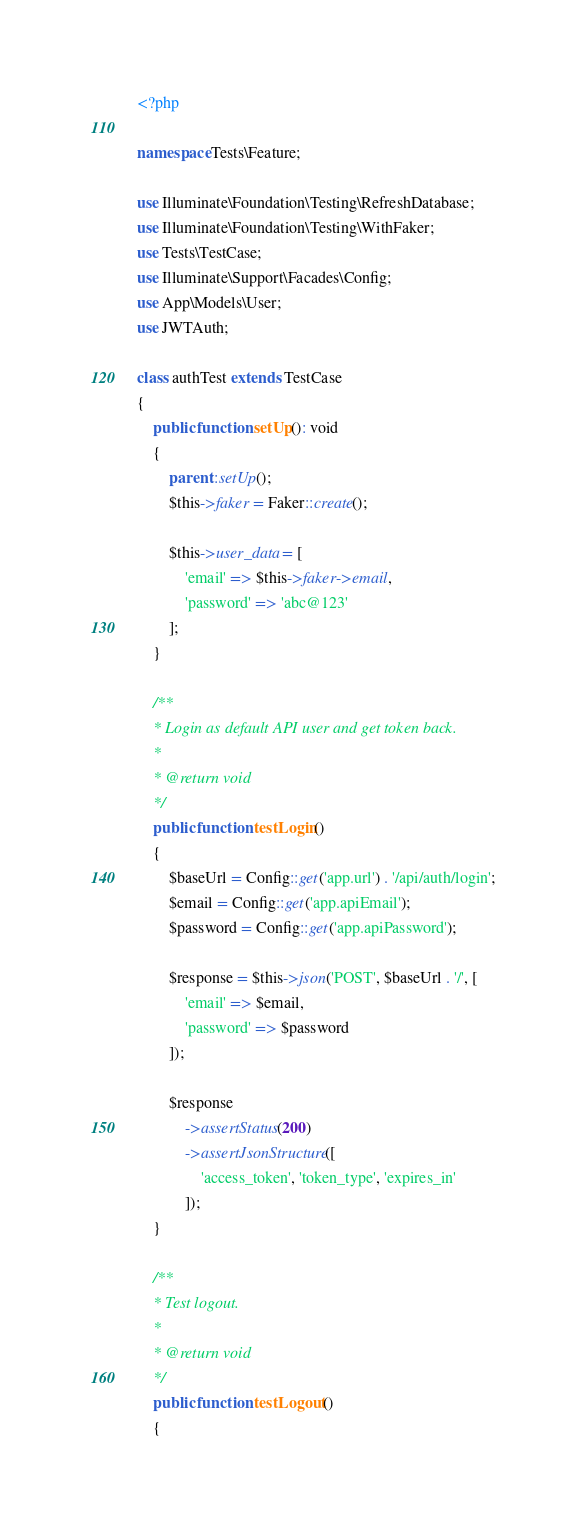<code> <loc_0><loc_0><loc_500><loc_500><_PHP_><?php

namespace Tests\Feature;

use Illuminate\Foundation\Testing\RefreshDatabase;
use Illuminate\Foundation\Testing\WithFaker;
use Tests\TestCase;
use Illuminate\Support\Facades\Config;
use App\Models\User;
use JWTAuth;

class authTest extends TestCase
{
    public function setUp(): void
    {
        parent::setUp();
        $this->faker = Faker::create();

        $this->user_data = [
            'email' => $this->faker->email,
            'password' => 'abc@123'
        ];
    }
    
    /**
    * Login as default API user and get token back.
    *
    * @return void
    */
    public function testLogin()
    {
        $baseUrl = Config::get('app.url') . '/api/auth/login';
        $email = Config::get('app.apiEmail');
        $password = Config::get('app.apiPassword');

        $response = $this->json('POST', $baseUrl . '/', [
            'email' => $email,
            'password' => $password
        ]);

        $response
            ->assertStatus(200)
            ->assertJsonStructure([
                'access_token', 'token_type', 'expires_in'
            ]);
    }

    /**
    * Test logout.
    *
    * @return void
    */
    public function testLogout()
    {</code> 